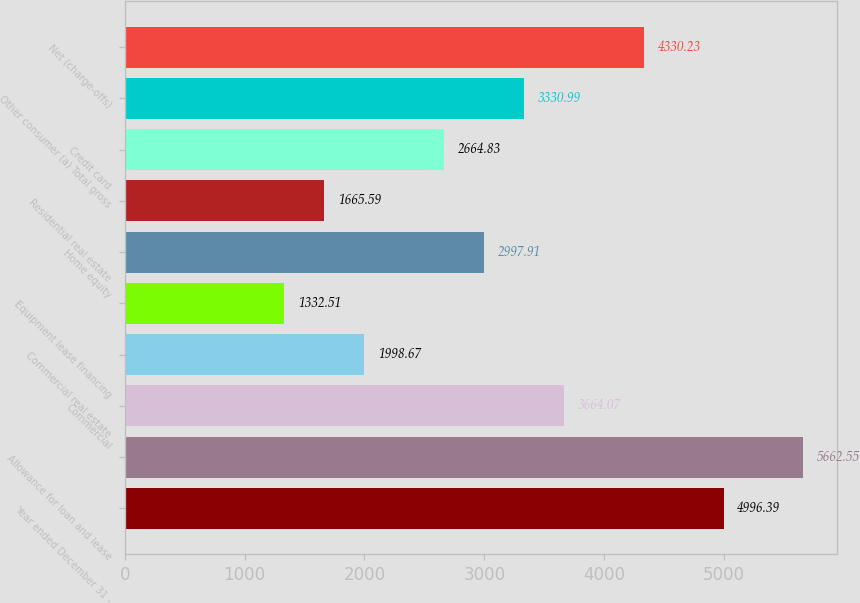Convert chart to OTSL. <chart><loc_0><loc_0><loc_500><loc_500><bar_chart><fcel>Year ended December 31 -<fcel>Allowance for loan and lease<fcel>Commercial<fcel>Commercial real estate<fcel>Equipment lease financing<fcel>Home equity<fcel>Residential real estate<fcel>Credit card<fcel>Other consumer (a) Total gross<fcel>Net (charge-offs)<nl><fcel>4996.39<fcel>5662.55<fcel>3664.07<fcel>1998.67<fcel>1332.51<fcel>2997.91<fcel>1665.59<fcel>2664.83<fcel>3330.99<fcel>4330.23<nl></chart> 